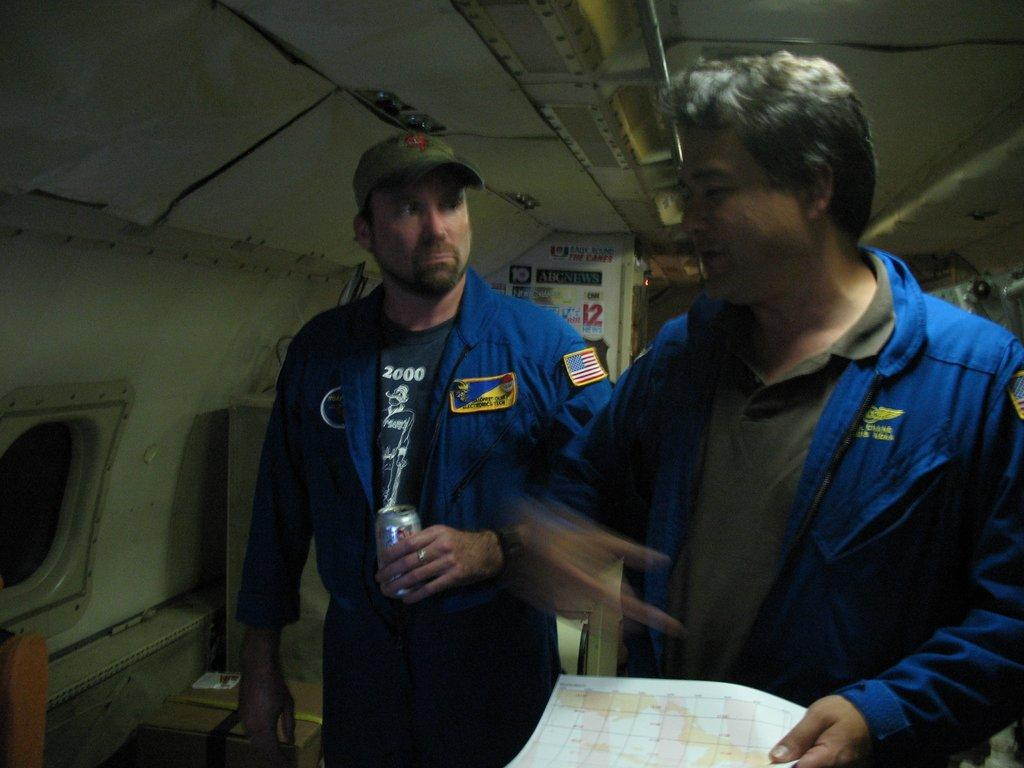How many people are in the image? There are two persons in the image. What are the people wearing? Both persons are wearing blue jackets. What can be seen on the left side of the image? There is a window on the left side of the image. What is visible at the top of the image? The ceiling is visible at the top of the image. What flavor of cherry can be seen in the image? There is no cherry present in the image. What type of bait is being used by the persons in the image? There is no indication of fishing or bait in the image; the persons are wearing blue jackets and there is a window and ceiling visible. 